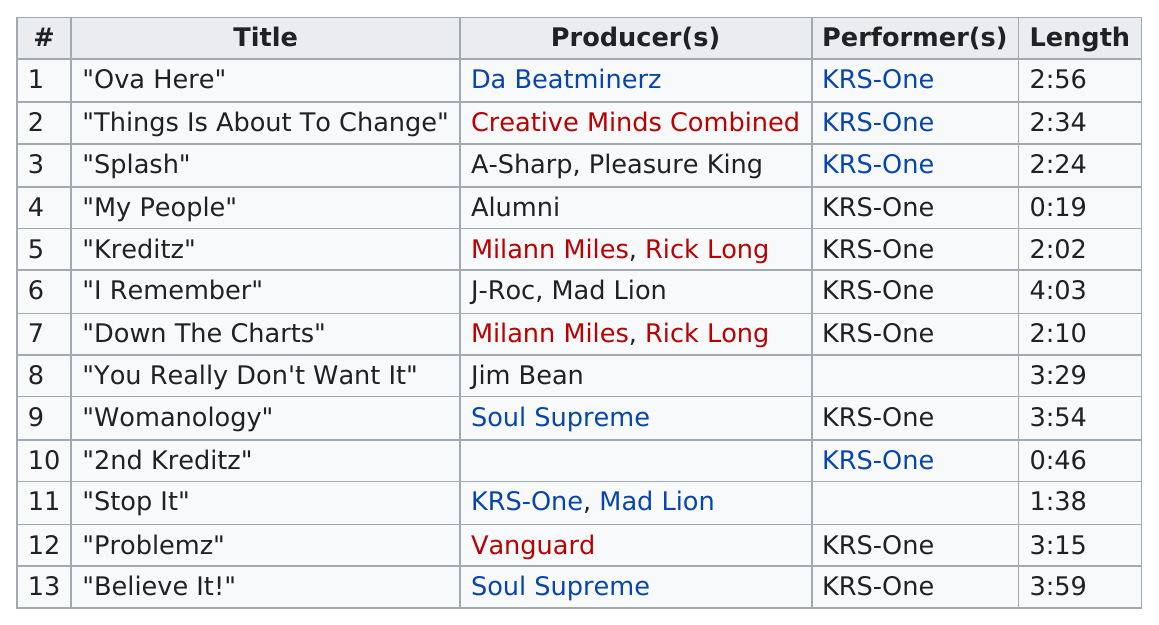List a handful of essential elements in this visual. The shortest track had a length of 0:19. There are two tracks that are under one minute in length. The song on the album Prophets vs. Profits that does not have a producer is titled '2nd Kreditz'. The shortest song from the album is called "My People". The longest song is 4 minutes and 3 seconds in length. 